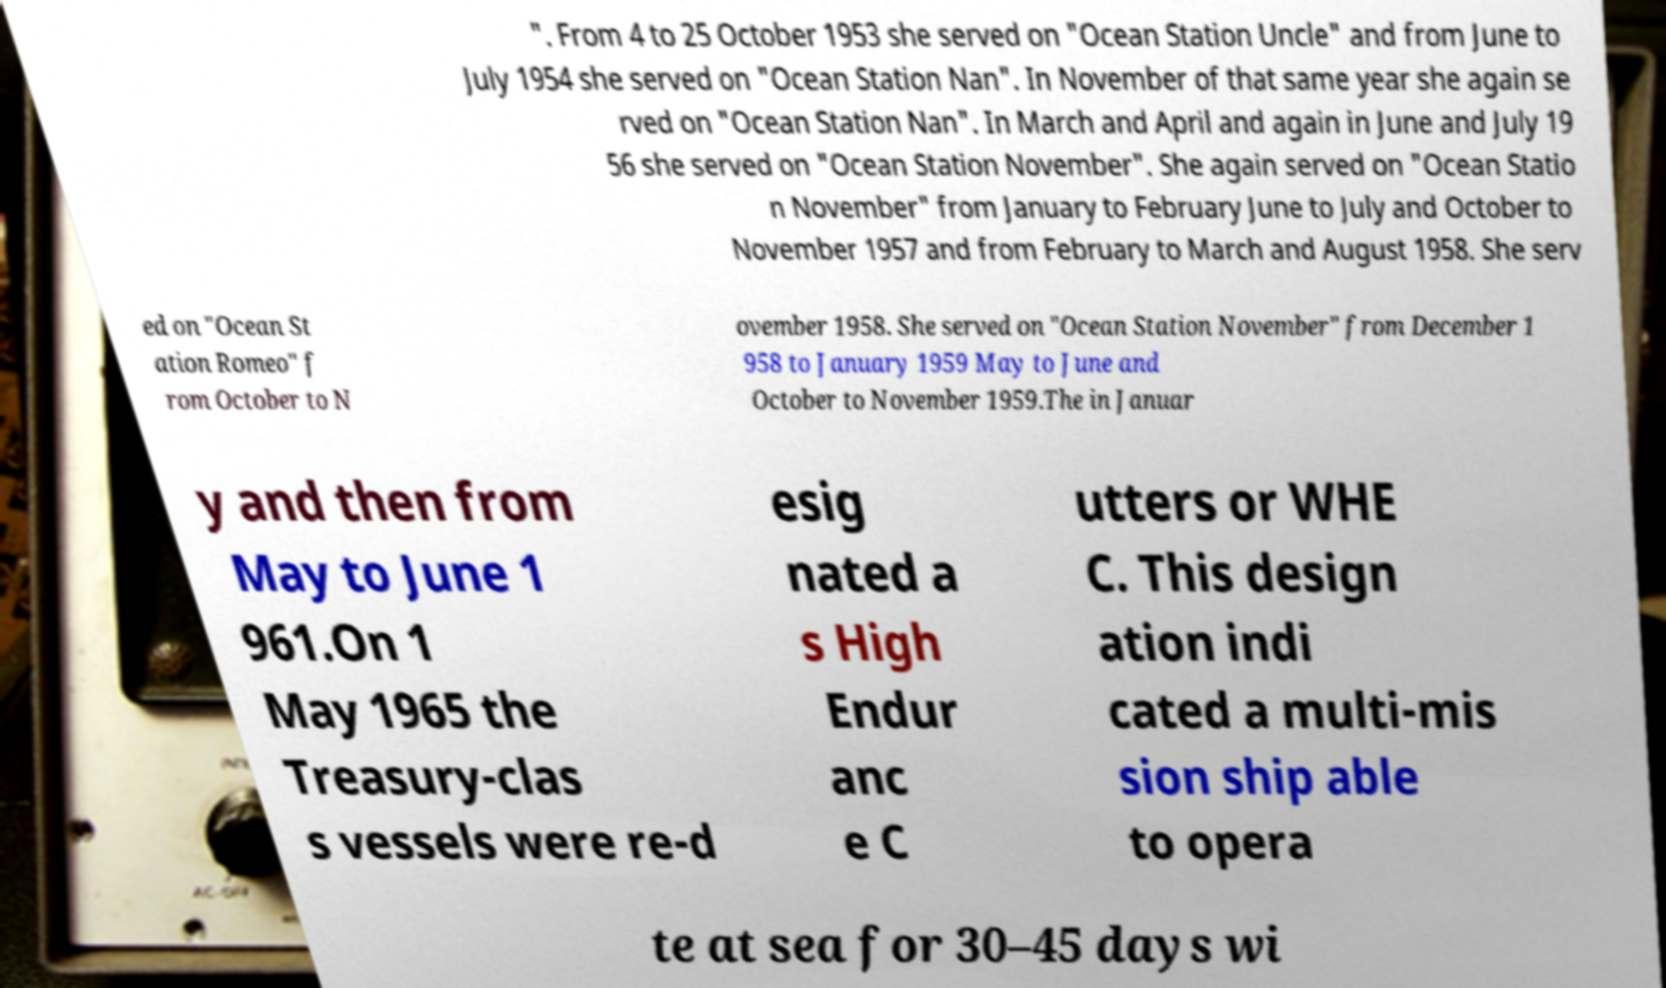Could you assist in decoding the text presented in this image and type it out clearly? ". From 4 to 25 October 1953 she served on "Ocean Station Uncle" and from June to July 1954 she served on "Ocean Station Nan". In November of that same year she again se rved on "Ocean Station Nan". In March and April and again in June and July 19 56 she served on "Ocean Station November". She again served on "Ocean Statio n November" from January to February June to July and October to November 1957 and from February to March and August 1958. She serv ed on "Ocean St ation Romeo" f rom October to N ovember 1958. She served on "Ocean Station November" from December 1 958 to January 1959 May to June and October to November 1959.The in Januar y and then from May to June 1 961.On 1 May 1965 the Treasury-clas s vessels were re-d esig nated a s High Endur anc e C utters or WHE C. This design ation indi cated a multi-mis sion ship able to opera te at sea for 30–45 days wi 